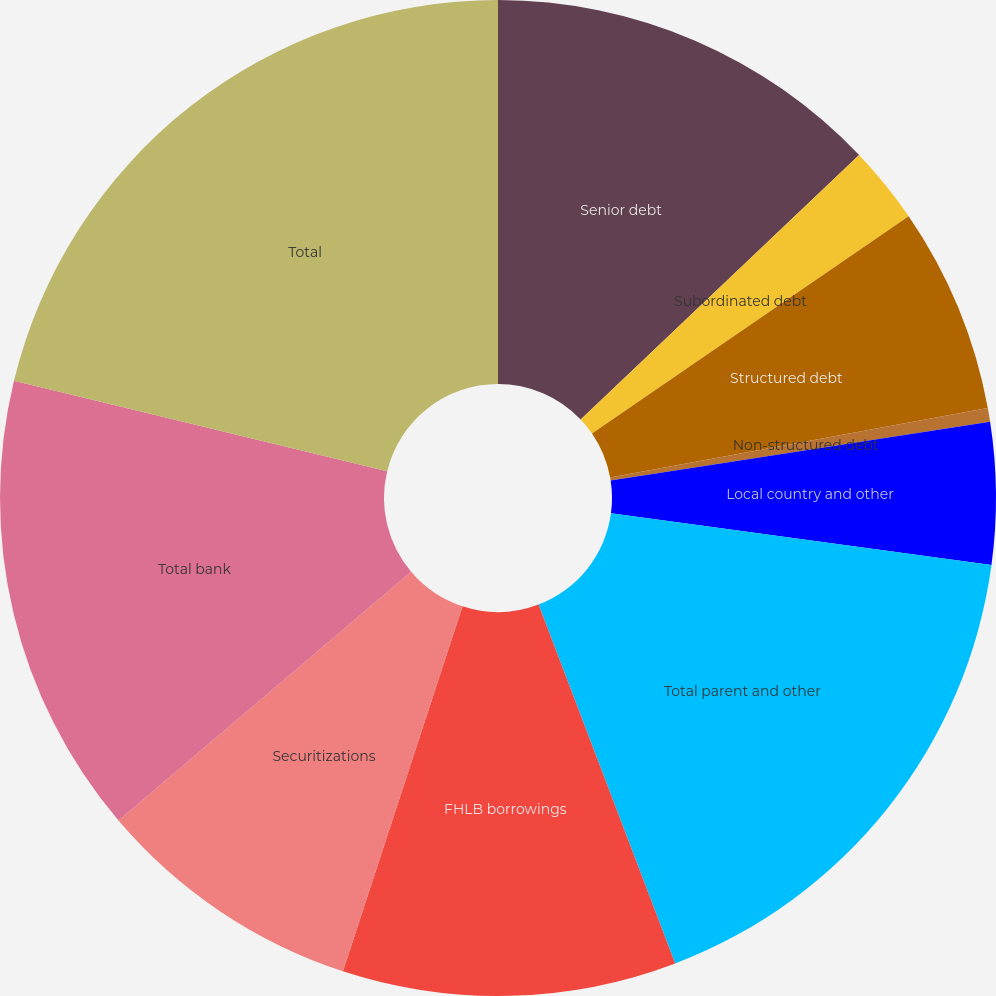<chart> <loc_0><loc_0><loc_500><loc_500><pie_chart><fcel>Senior debt<fcel>Subordinated debt<fcel>Structured debt<fcel>Non-structured debt<fcel>Local country and other<fcel>Total parent and other<fcel>FHLB borrowings<fcel>Securitizations<fcel>Total bank<fcel>Total<nl><fcel>12.91%<fcel>2.52%<fcel>6.68%<fcel>0.44%<fcel>4.6%<fcel>17.06%<fcel>10.83%<fcel>8.75%<fcel>14.99%<fcel>21.22%<nl></chart> 